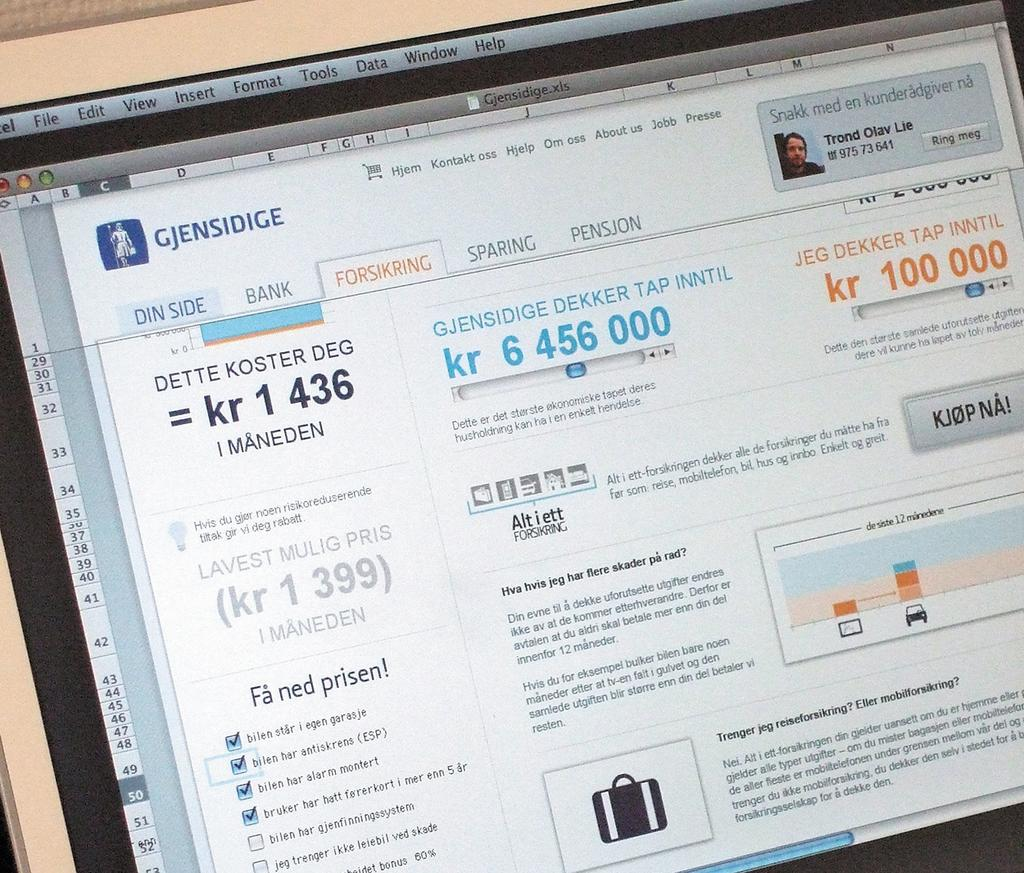<image>
Create a compact narrative representing the image presented. A computer screen displays a web page with Gjensidige in the upper right corner. 